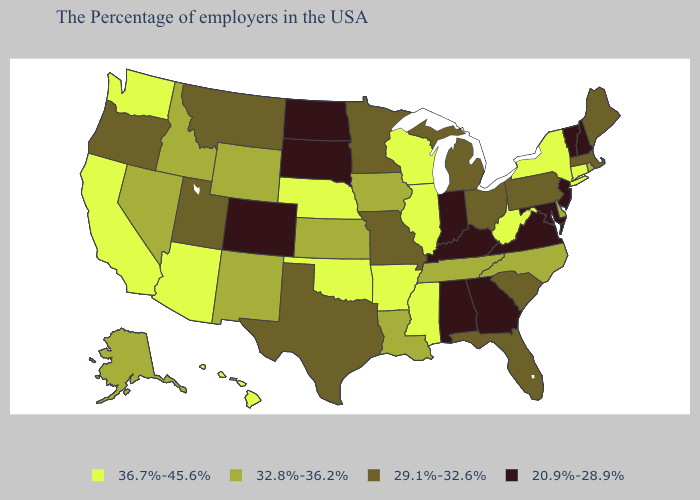Does Pennsylvania have the lowest value in the Northeast?
Concise answer only. No. Among the states that border New Mexico , which have the highest value?
Concise answer only. Oklahoma, Arizona. Name the states that have a value in the range 29.1%-32.6%?
Write a very short answer. Maine, Massachusetts, Pennsylvania, South Carolina, Ohio, Florida, Michigan, Missouri, Minnesota, Texas, Utah, Montana, Oregon. Name the states that have a value in the range 29.1%-32.6%?
Keep it brief. Maine, Massachusetts, Pennsylvania, South Carolina, Ohio, Florida, Michigan, Missouri, Minnesota, Texas, Utah, Montana, Oregon. Among the states that border Iowa , which have the lowest value?
Concise answer only. South Dakota. Which states hav the highest value in the MidWest?
Write a very short answer. Wisconsin, Illinois, Nebraska. Does Rhode Island have a lower value than Colorado?
Give a very brief answer. No. Does the first symbol in the legend represent the smallest category?
Keep it brief. No. What is the value of Texas?
Concise answer only. 29.1%-32.6%. Name the states that have a value in the range 29.1%-32.6%?
Answer briefly. Maine, Massachusetts, Pennsylvania, South Carolina, Ohio, Florida, Michigan, Missouri, Minnesota, Texas, Utah, Montana, Oregon. Does the first symbol in the legend represent the smallest category?
Quick response, please. No. What is the highest value in the USA?
Write a very short answer. 36.7%-45.6%. Name the states that have a value in the range 29.1%-32.6%?
Give a very brief answer. Maine, Massachusetts, Pennsylvania, South Carolina, Ohio, Florida, Michigan, Missouri, Minnesota, Texas, Utah, Montana, Oregon. Which states have the highest value in the USA?
Give a very brief answer. Connecticut, New York, West Virginia, Wisconsin, Illinois, Mississippi, Arkansas, Nebraska, Oklahoma, Arizona, California, Washington, Hawaii. 